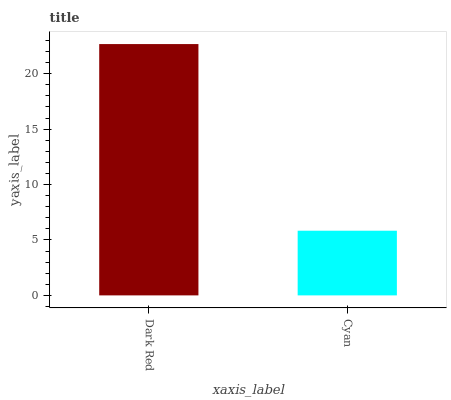Is Cyan the minimum?
Answer yes or no. Yes. Is Dark Red the maximum?
Answer yes or no. Yes. Is Cyan the maximum?
Answer yes or no. No. Is Dark Red greater than Cyan?
Answer yes or no. Yes. Is Cyan less than Dark Red?
Answer yes or no. Yes. Is Cyan greater than Dark Red?
Answer yes or no. No. Is Dark Red less than Cyan?
Answer yes or no. No. Is Dark Red the high median?
Answer yes or no. Yes. Is Cyan the low median?
Answer yes or no. Yes. Is Cyan the high median?
Answer yes or no. No. Is Dark Red the low median?
Answer yes or no. No. 